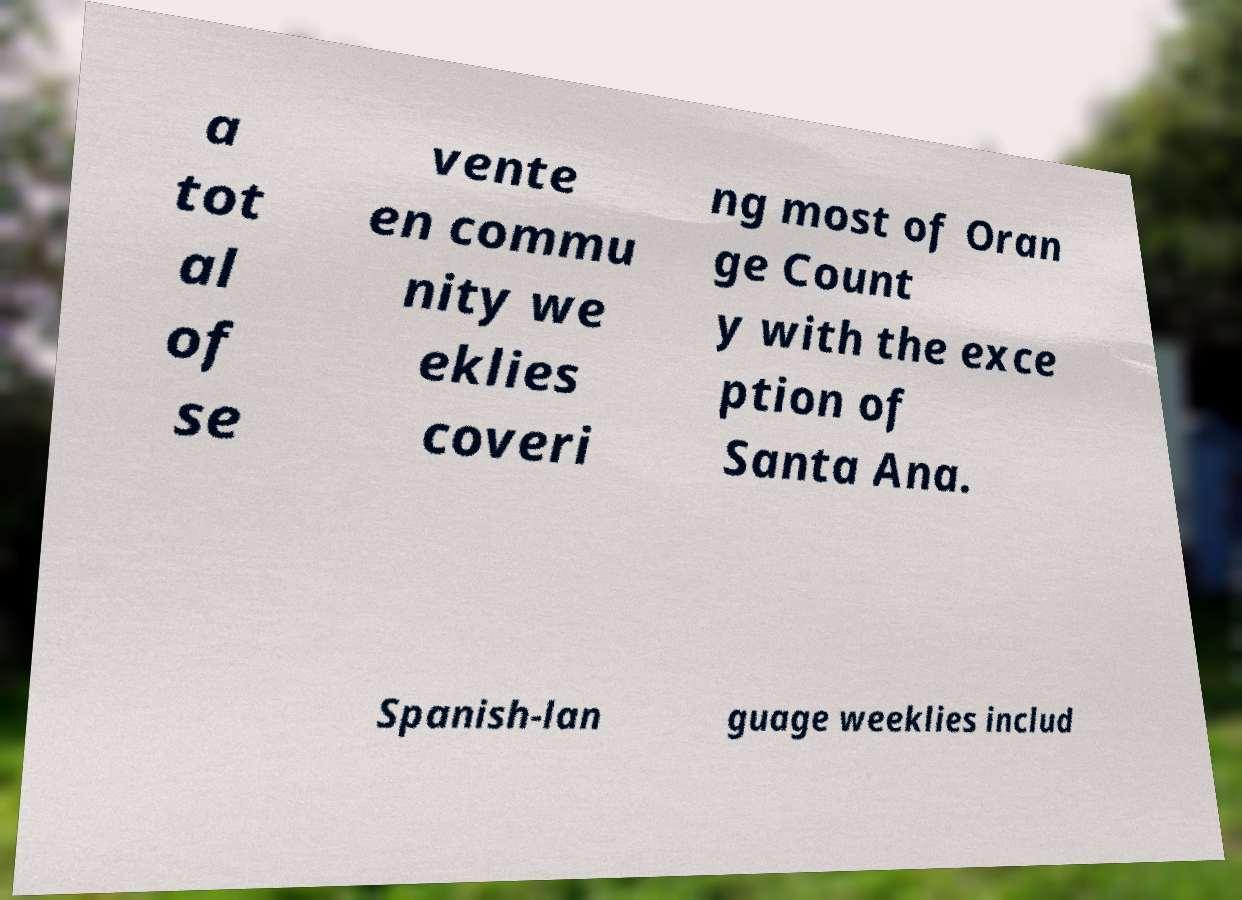Can you read and provide the text displayed in the image?This photo seems to have some interesting text. Can you extract and type it out for me? a tot al of se vente en commu nity we eklies coveri ng most of Oran ge Count y with the exce ption of Santa Ana. Spanish-lan guage weeklies includ 